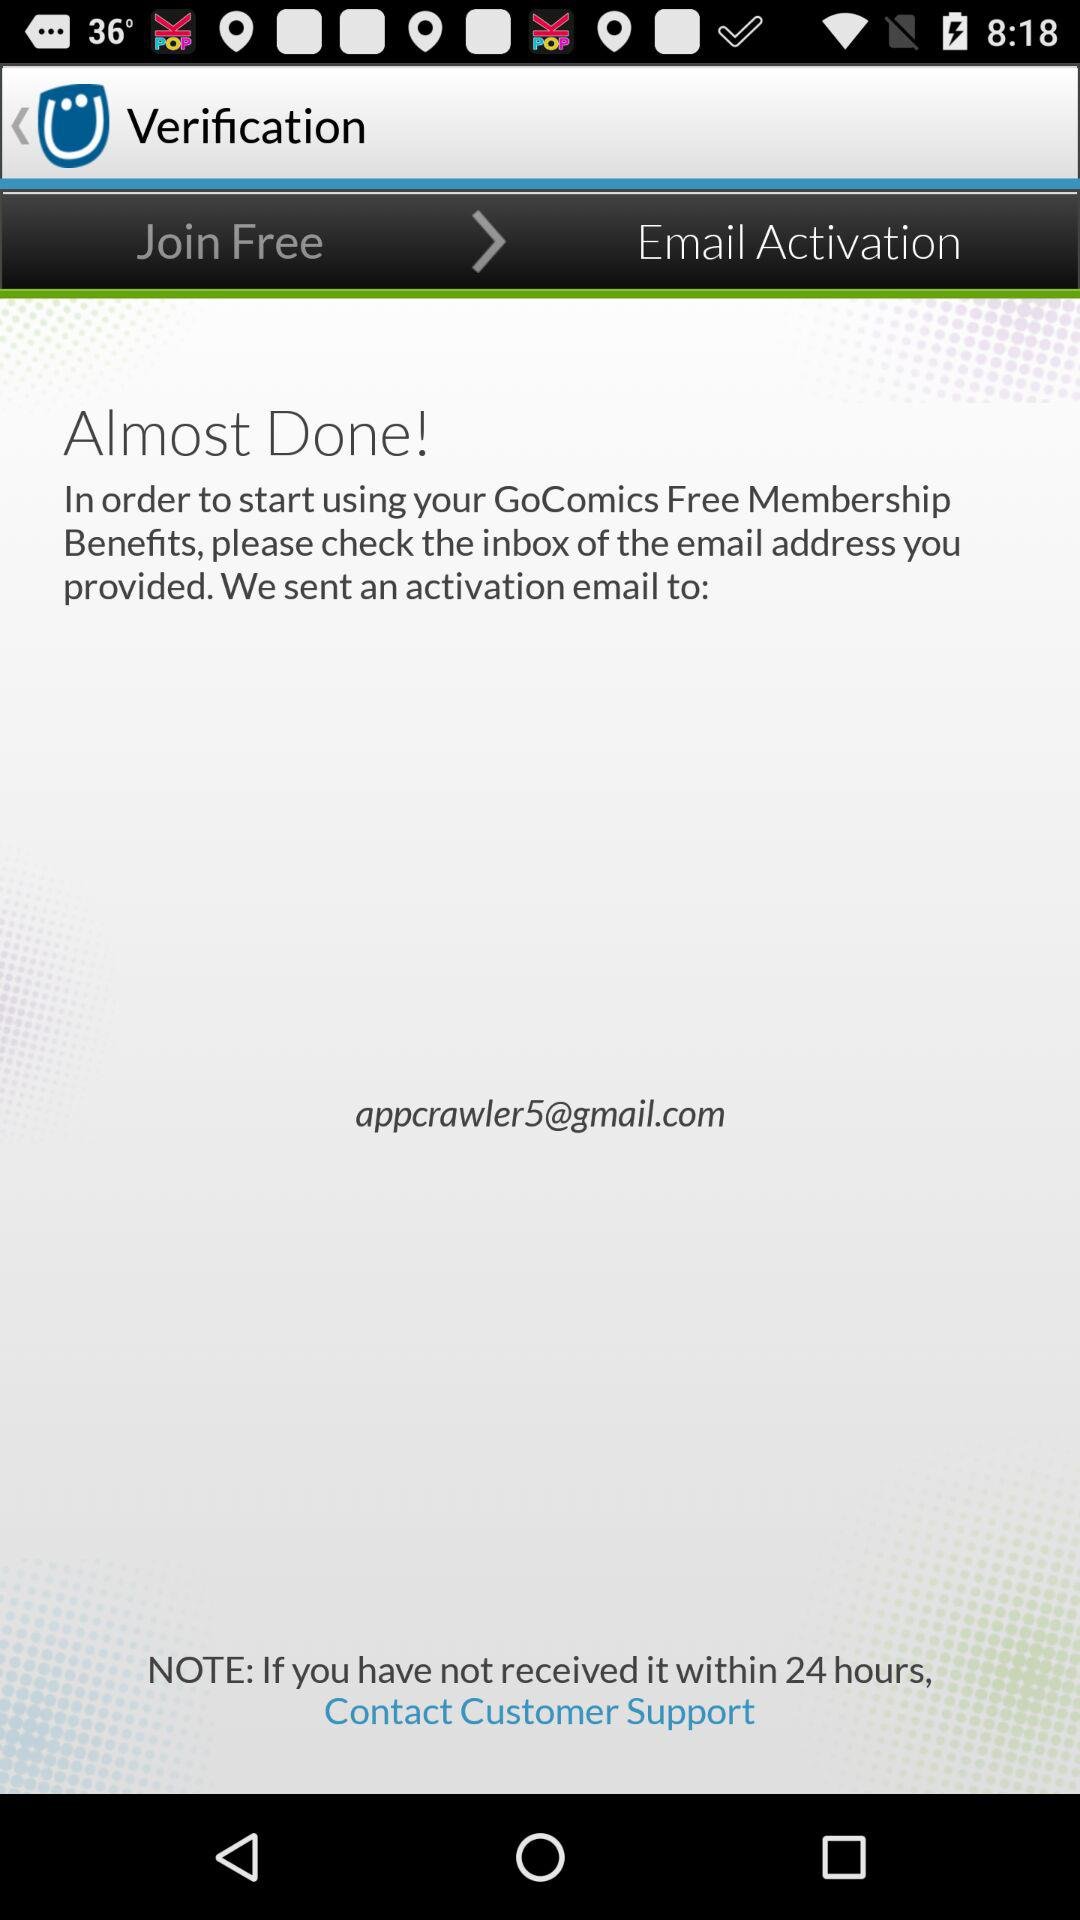What is the email address? The email address is appcrawler5@gmail.com. 